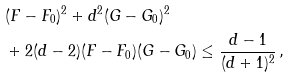Convert formula to latex. <formula><loc_0><loc_0><loc_500><loc_500>& ( F - F _ { 0 } ) ^ { 2 } + d ^ { 2 } ( G - G _ { 0 } ) ^ { 2 } \\ & + 2 ( d - 2 ) ( F - F _ { 0 } ) ( G - G _ { 0 } ) \leq \frac { d - 1 } { ( d + 1 ) ^ { 2 } } \, ,</formula> 